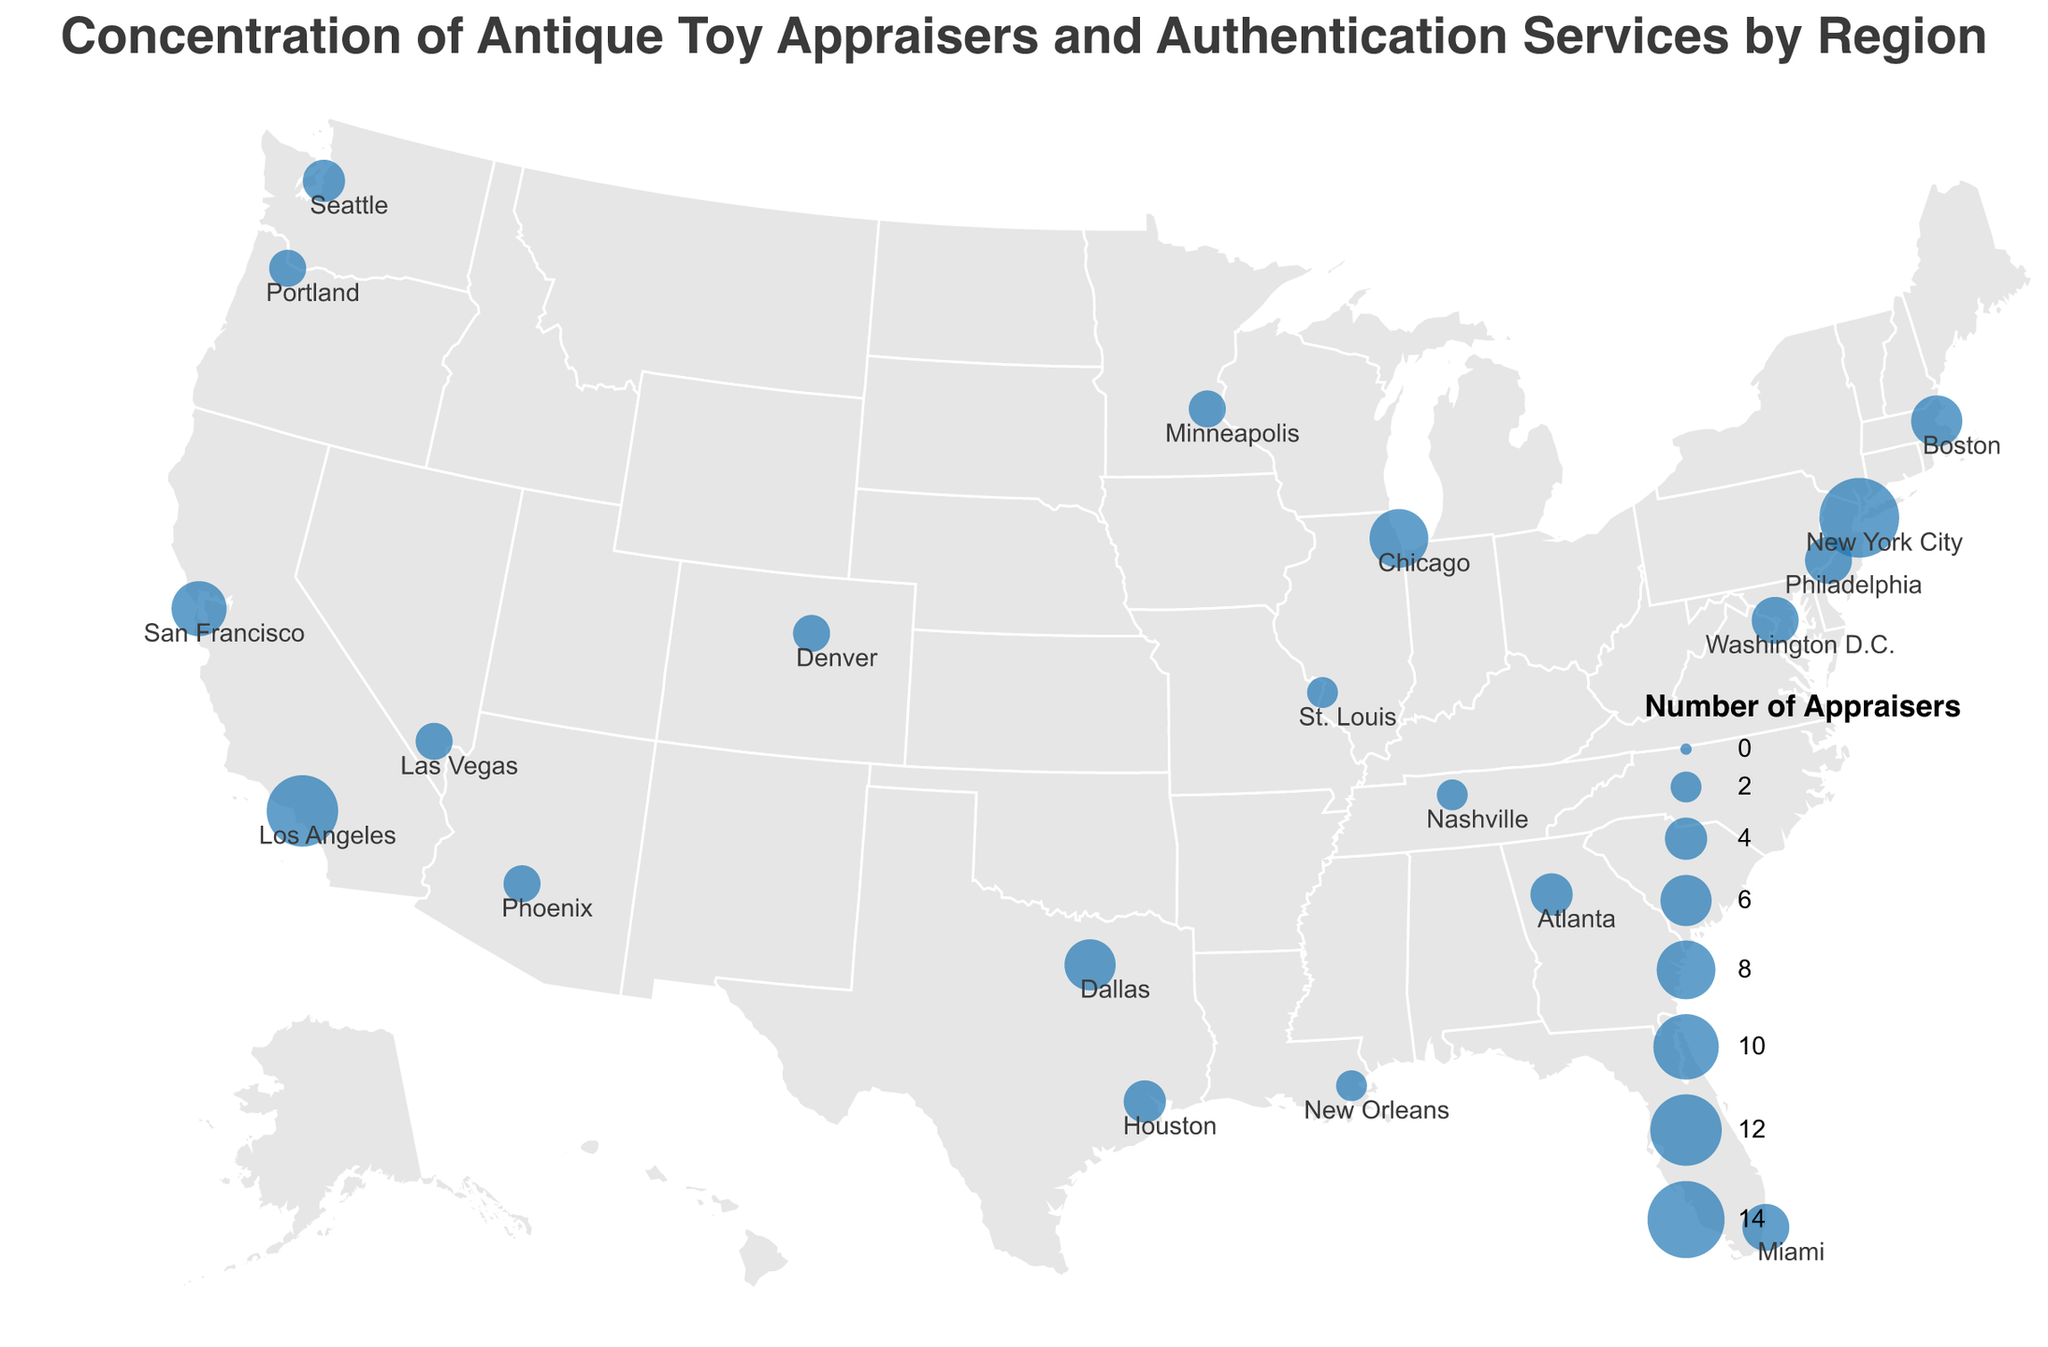what's the title of the figure? The title is located at the top of the figure and typically summarizes the main subject or finding. Here, it reads: "Concentration of Antique Toy Appraisers and Authentication Services by Region".
Answer: Concentration of Antique Toy Appraisers and Authentication Services by Region Which region has the most appraisers? By examining the size of the circles on the map, the largest one appears over New York City, indicating the highest number of appraisers, which is 15.
Answer: New York City What's the difference in the number of appraisers between New York City and Los Angeles? New York City has 15 appraisers, and Los Angeles has 12. Calculating the difference: 15 - 12 = 3.
Answer: 3 How many regions have exactly 3 appraisers? By scanning the figure, Portland, Denver, Las Vegas, Minneapolis, and Phoenix each have circles sized to indicate 3 appraisers. Counting them gives five regions.
Answer: Five Which region has the least number of appraisers and how many do they have? The smallest circles represent the least number of appraisers. Nashville, St. Louis, and New Orleans each have the smallest circles indicating 2 appraisers.
Answer: Nashville, St. Louis, New Orleans Is there a pattern in the distribution of appraisers on the east versus the west coast? Observing the map, the east coast (New York City, Philadelphia, Boston, Washington D.C., Miami) generally has more and larger circles compared to the west coast (Los Angeles, San Francisco, Seattle, Portland). Therefore, the east coast has a higher concentration of appraisers on average.
Answer: East coast has more appraisers on average Which region has the second-highest number of appraisers, and how many do they have? The second-largest circle appears over Los Angeles, indicating a number of 12 appraisers, just below New York City's 15.
Answer: Los Angeles, 12 What's the average number of authentication services per region? Summing the authentication services across all regions (5 + 4 + 3 + 2 + 2 + 3 + 2 + 1 + 2 + 1 + 1 + 1 + 1 + 1 + 2 + 1 + 1 + 1 + 1 + 1) results in 40. Dividing by the number of regions (20), the average is 40 / 20 = 2.
Answer: 2 Which regions have more than one authentication service but less than 5 appraisers? Regions with more than one authentication service and less than 5 appraisers are Miami, Philadelphia, and Washington D.C., all with circles indicating these metrics.
Answer: Miami, Philadelphia, Washington D.C How does the number of appraisers in Chicago compare to Dallas? Chicago has 8 appraisers while Dallas has 6. Therefore, Chicago has 2 more appraisers than Dallas.
Answer: Chicago has 2 more appraisers than Dallas 